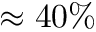<formula> <loc_0><loc_0><loc_500><loc_500>\approx 4 0 \%</formula> 